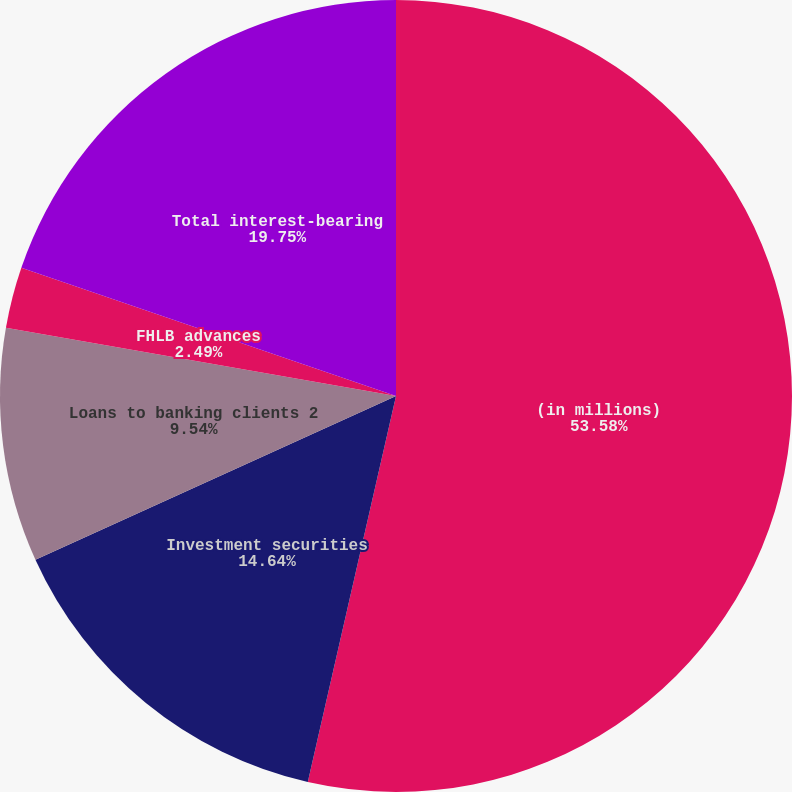<chart> <loc_0><loc_0><loc_500><loc_500><pie_chart><fcel>(in millions)<fcel>Investment securities<fcel>Loans to banking clients 2<fcel>FHLB advances<fcel>Total interest-bearing<nl><fcel>53.57%<fcel>14.64%<fcel>9.54%<fcel>2.49%<fcel>19.75%<nl></chart> 